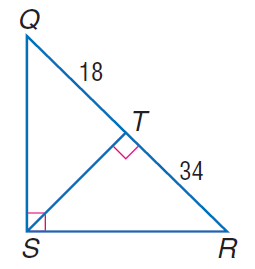Answer the mathemtical geometry problem and directly provide the correct option letter.
Question: Find the measure of the altitude drawn to the hypotenuse.
Choices: A: 18 B: \sqrt { 612 } C: 34 D: 612 B 